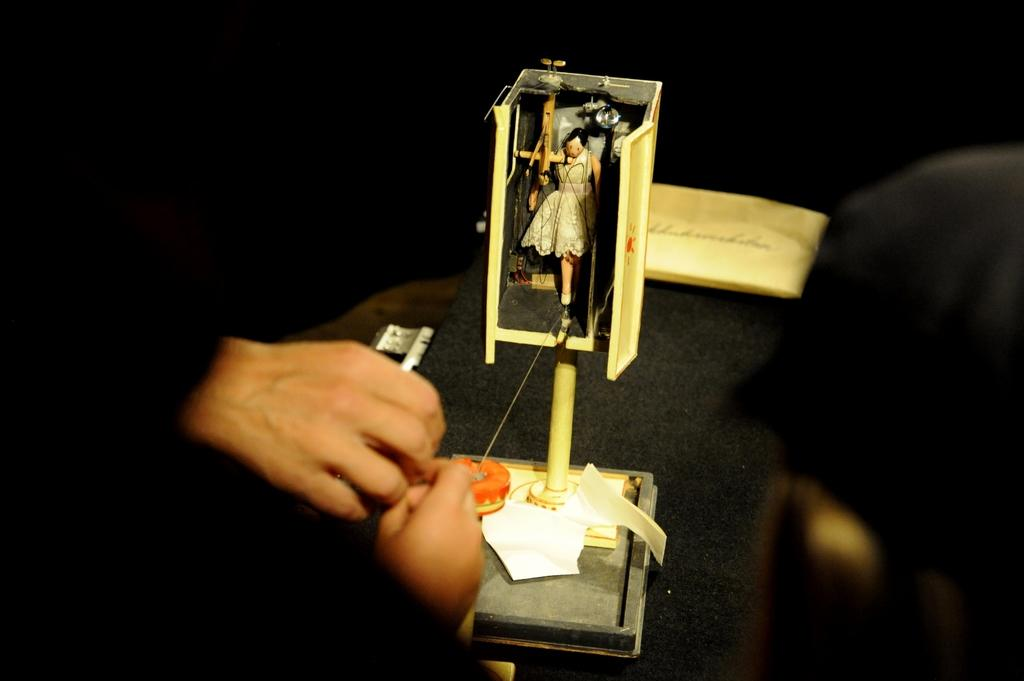What body parts are visible in the image? There are human hands in the image. What type of object can be seen in the image? There is a figurine in the image. What color is the background of the image? The background of the image is black. Reasoning: Let' Let's think step by step in order to produce the conversation. We start by identifying the main subjects in the image, which are the human hands and the figurine. Then, we describe the background color, which is black. Each question is designed to elicit a specific detail about the image that is known from the provided facts. Absurd Question/Answer: What number is written as a caption for the figurine? There is no number or caption present in the image. Are there any police officers visible in the image? There are no police officers present in the image. What type of animal is the police officer riding in the image? There are no animals or police officers present in the image. 